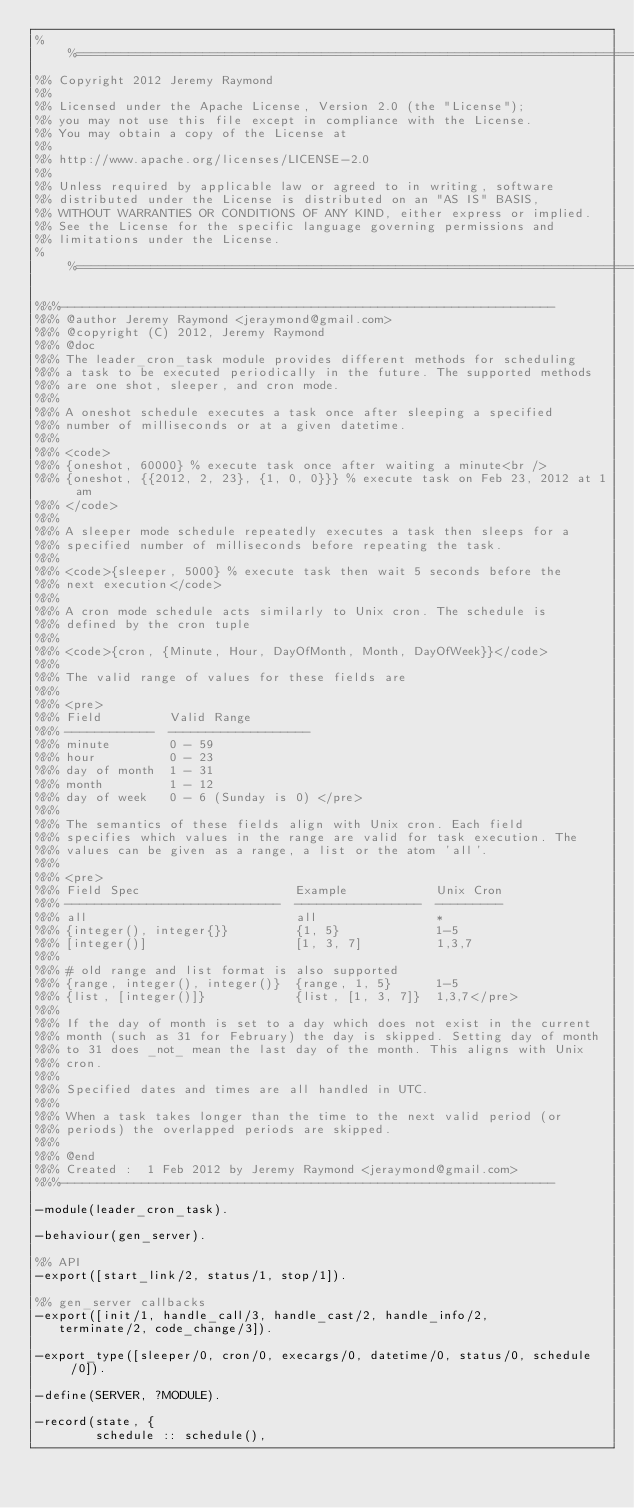Convert code to text. <code><loc_0><loc_0><loc_500><loc_500><_Erlang_>%%==============================================================================
%% Copyright 2012 Jeremy Raymond
%%
%% Licensed under the Apache License, Version 2.0 (the "License");
%% you may not use this file except in compliance with the License.
%% You may obtain a copy of the License at
%%
%% http://www.apache.org/licenses/LICENSE-2.0
%%
%% Unless required by applicable law or agreed to in writing, software
%% distributed under the License is distributed on an "AS IS" BASIS,
%% WITHOUT WARRANTIES OR CONDITIONS OF ANY KIND, either express or implied.
%% See the License for the specific language governing permissions and
%% limitations under the License.
%%==============================================================================

%%%-------------------------------------------------------------------
%%% @author Jeremy Raymond <jeraymond@gmail.com>
%%% @copyright (C) 2012, Jeremy Raymond
%%% @doc
%%% The leader_cron_task module provides different methods for scheduling
%%% a task to be executed periodically in the future. The supported methods
%%% are one shot, sleeper, and cron mode.
%%%
%%% A oneshot schedule executes a task once after sleeping a specified
%%% number of milliseconds or at a given datetime.
%%%
%%% <code>
%%% {oneshot, 60000} % execute task once after waiting a minute<br />
%%% {oneshot, {{2012, 2, 23}, {1, 0, 0}}} % execute task on Feb 23, 2012 at 1 am
%%% </code>
%%%
%%% A sleeper mode schedule repeatedly executes a task then sleeps for a
%%% specified number of milliseconds before repeating the task.
%%%
%%% <code>{sleeper, 5000} % execute task then wait 5 seconds before the
%%% next execution</code>
%%%
%%% A cron mode schedule acts similarly to Unix cron. The schedule is
%%% defined by the cron tuple
%%%
%%% <code>{cron, {Minute, Hour, DayOfMonth, Month, DayOfWeek}}</code>
%%%
%%% The valid range of values for these fields are
%%%
%%% <pre>
%%% Field         Valid Range
%%% ------------  -------------------
%%% minute        0 - 59
%%% hour          0 - 23
%%% day of month  1 - 31
%%% month         1 - 12
%%% day of week   0 - 6 (Sunday is 0) </pre>
%%%
%%% The semantics of these fields align with Unix cron. Each field
%%% specifies which values in the range are valid for task execution. The
%%% values can be given as a range, a list or the atom 'all'.
%%%
%%% <pre>
%%% Field Spec                     Example            Unix Cron
%%% -----------------------------  -----------------  ---------
%%% all                            all                *
%%% {integer(), integer{}}         {1, 5}             1-5
%%% [integer()]                    [1, 3, 7]          1,3,7
%%%
%%% # old range and list format is also supported
%%% {range, integer(), integer()}  {range, 1, 5}      1-5
%%% {list, [integer()]}            {list, [1, 3, 7]}  1,3,7</pre>
%%%
%%% If the day of month is set to a day which does not exist in the current
%%% month (such as 31 for February) the day is skipped. Setting day of month
%%% to 31 does _not_ mean the last day of the month. This aligns with Unix
%%% cron.
%%%
%%% Specified dates and times are all handled in UTC.
%%%
%%% When a task takes longer than the time to the next valid period (or
%%% periods) the overlapped periods are skipped.
%%%
%%% @end
%%% Created :  1 Feb 2012 by Jeremy Raymond <jeraymond@gmail.com>
%%%-------------------------------------------------------------------

-module(leader_cron_task).

-behaviour(gen_server).

%% API
-export([start_link/2, status/1, stop/1]).

%% gen_server callbacks
-export([init/1, handle_call/3, handle_cast/2, handle_info/2,
	 terminate/2, code_change/3]).

-export_type([sleeper/0, cron/0, execargs/0, datetime/0, status/0, schedule/0]).

-define(SERVER, ?MODULE).

-record(state, {
        schedule :: schedule(),</code> 